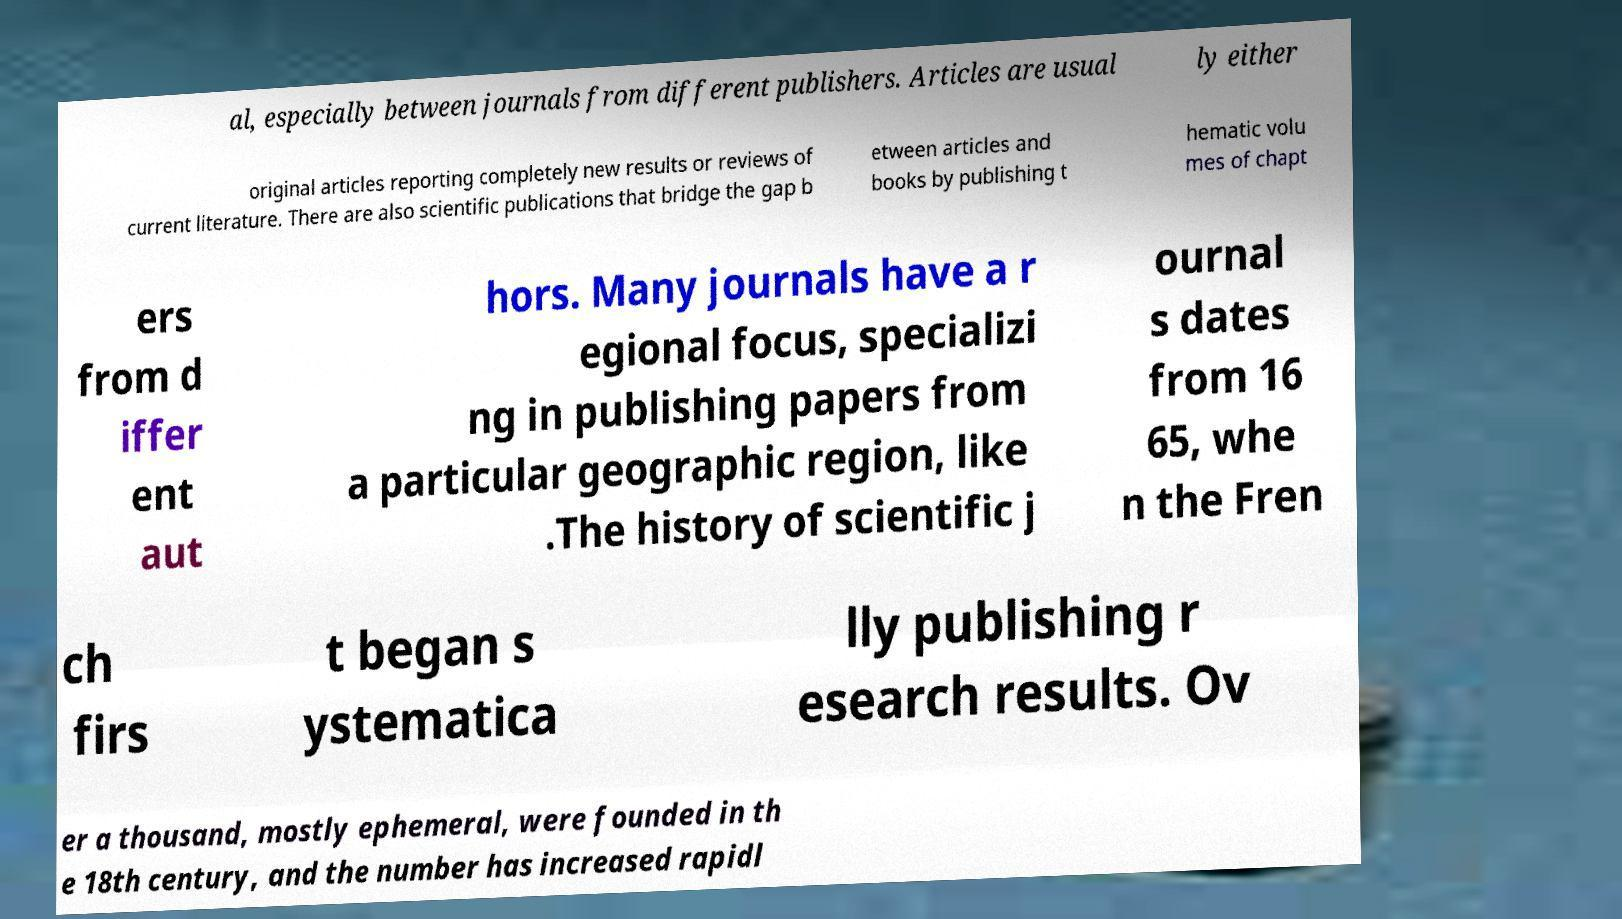Can you accurately transcribe the text from the provided image for me? al, especially between journals from different publishers. Articles are usual ly either original articles reporting completely new results or reviews of current literature. There are also scientific publications that bridge the gap b etween articles and books by publishing t hematic volu mes of chapt ers from d iffer ent aut hors. Many journals have a r egional focus, specializi ng in publishing papers from a particular geographic region, like .The history of scientific j ournal s dates from 16 65, whe n the Fren ch firs t began s ystematica lly publishing r esearch results. Ov er a thousand, mostly ephemeral, were founded in th e 18th century, and the number has increased rapidl 